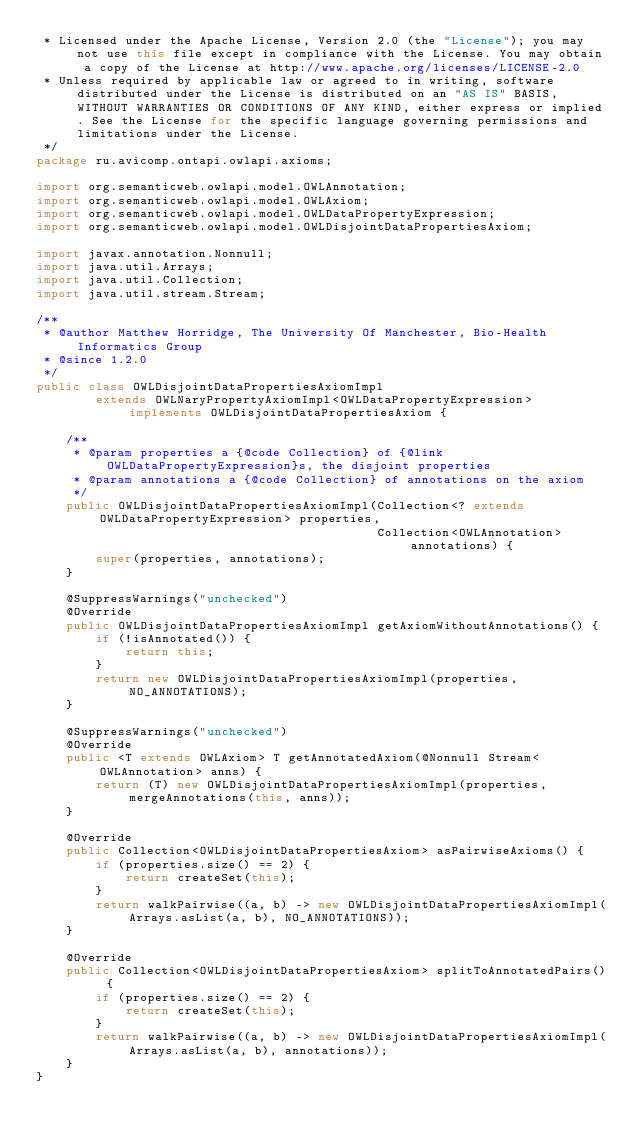Convert code to text. <code><loc_0><loc_0><loc_500><loc_500><_Java_> * Licensed under the Apache License, Version 2.0 (the "License"); you may not use this file except in compliance with the License. You may obtain a copy of the License at http://www.apache.org/licenses/LICENSE-2.0
 * Unless required by applicable law or agreed to in writing, software distributed under the License is distributed on an "AS IS" BASIS, WITHOUT WARRANTIES OR CONDITIONS OF ANY KIND, either express or implied. See the License for the specific language governing permissions and limitations under the License.
 */
package ru.avicomp.ontapi.owlapi.axioms;

import org.semanticweb.owlapi.model.OWLAnnotation;
import org.semanticweb.owlapi.model.OWLAxiom;
import org.semanticweb.owlapi.model.OWLDataPropertyExpression;
import org.semanticweb.owlapi.model.OWLDisjointDataPropertiesAxiom;

import javax.annotation.Nonnull;
import java.util.Arrays;
import java.util.Collection;
import java.util.stream.Stream;

/**
 * @author Matthew Horridge, The University Of Manchester, Bio-Health Informatics Group
 * @since 1.2.0
 */
public class OWLDisjointDataPropertiesAxiomImpl
        extends OWLNaryPropertyAxiomImpl<OWLDataPropertyExpression> implements OWLDisjointDataPropertiesAxiom {

    /**
     * @param properties a {@code Collection} of {@link OWLDataPropertyExpression}s, the disjoint properties
     * @param annotations a {@code Collection} of annotations on the axiom
     */
    public OWLDisjointDataPropertiesAxiomImpl(Collection<? extends OWLDataPropertyExpression> properties,
                                              Collection<OWLAnnotation> annotations) {
        super(properties, annotations);
    }

    @SuppressWarnings("unchecked")
    @Override
    public OWLDisjointDataPropertiesAxiomImpl getAxiomWithoutAnnotations() {
        if (!isAnnotated()) {
            return this;
        }
        return new OWLDisjointDataPropertiesAxiomImpl(properties, NO_ANNOTATIONS);
    }

    @SuppressWarnings("unchecked")
    @Override
    public <T extends OWLAxiom> T getAnnotatedAxiom(@Nonnull Stream<OWLAnnotation> anns) {
        return (T) new OWLDisjointDataPropertiesAxiomImpl(properties, mergeAnnotations(this, anns));
    }

    @Override
    public Collection<OWLDisjointDataPropertiesAxiom> asPairwiseAxioms() {
        if (properties.size() == 2) {
            return createSet(this);
        }
        return walkPairwise((a, b) -> new OWLDisjointDataPropertiesAxiomImpl(Arrays.asList(a, b), NO_ANNOTATIONS));
    }

    @Override
    public Collection<OWLDisjointDataPropertiesAxiom> splitToAnnotatedPairs() {
        if (properties.size() == 2) {
            return createSet(this);
        }
        return walkPairwise((a, b) -> new OWLDisjointDataPropertiesAxiomImpl(Arrays.asList(a, b), annotations));
    }
}
</code> 